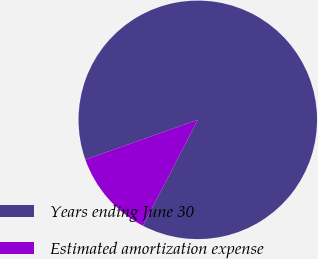Convert chart to OTSL. <chart><loc_0><loc_0><loc_500><loc_500><pie_chart><fcel>Years ending June 30<fcel>Estimated amortization expense<nl><fcel>88.01%<fcel>11.99%<nl></chart> 